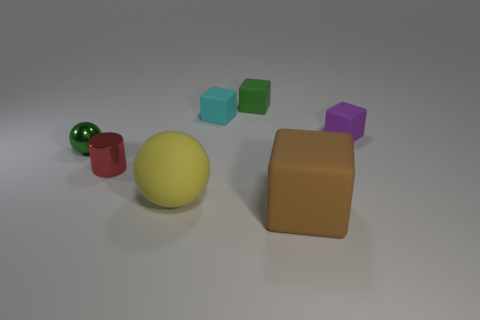Does the large sphere have the same color as the small cylinder?
Provide a succinct answer. No. What material is the object that is the same color as the shiny sphere?
Keep it short and to the point. Rubber. What size is the rubber block that is the same color as the shiny sphere?
Offer a very short reply. Small. Do the small cylinder and the ball that is behind the large yellow rubber object have the same material?
Make the answer very short. Yes. There is a matte block in front of the tiny thing to the right of the brown object; what is its color?
Your response must be concise. Brown. What is the size of the object that is both in front of the green metallic object and behind the yellow rubber ball?
Your response must be concise. Small. How many other things are the same shape as the red metal thing?
Your answer should be very brief. 0. There is a purple thing; is its shape the same as the red metal object in front of the small purple rubber object?
Offer a terse response. No. What number of purple cubes are right of the purple cube?
Keep it short and to the point. 0. Are there any other things that are made of the same material as the green ball?
Your answer should be very brief. Yes. 